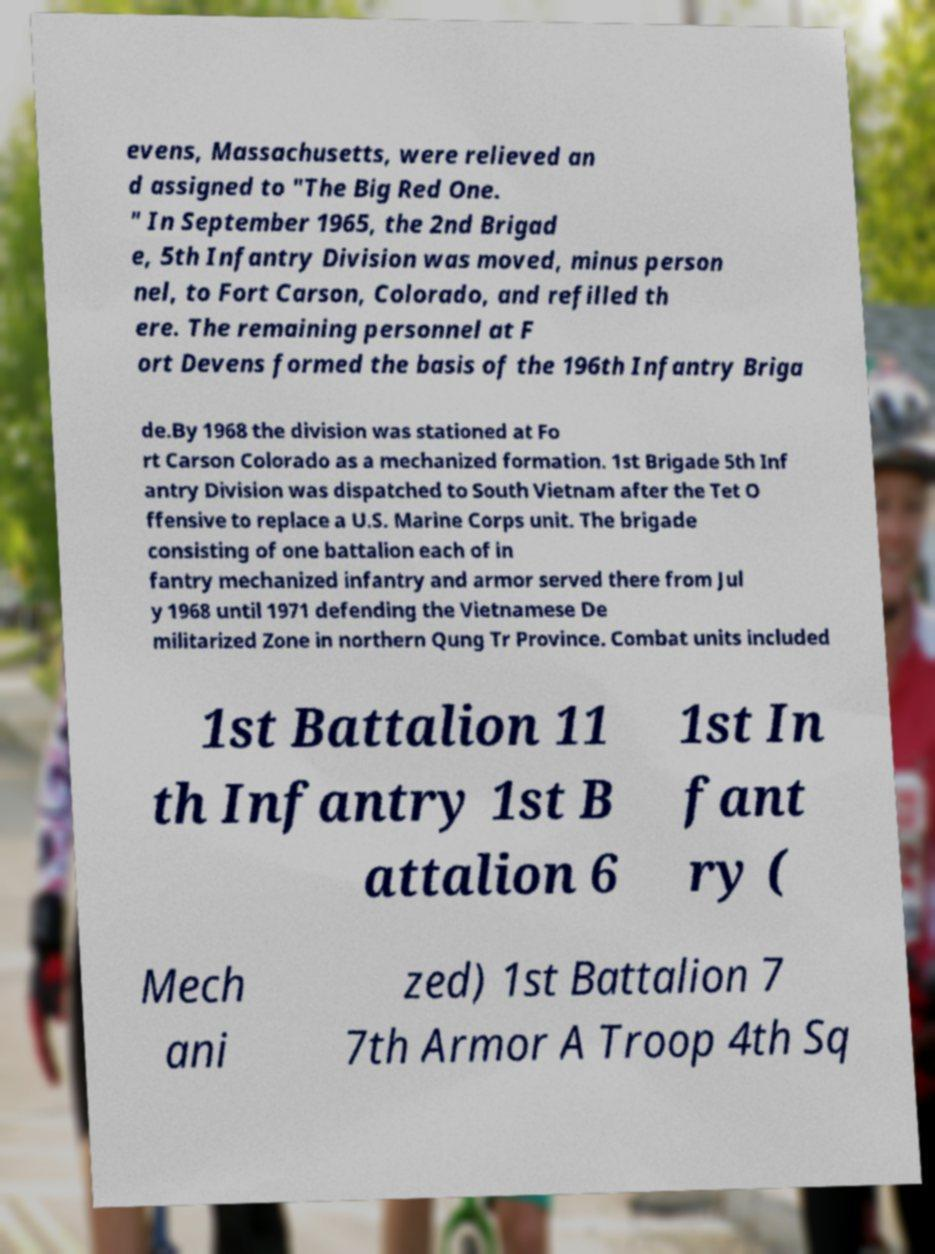For documentation purposes, I need the text within this image transcribed. Could you provide that? evens, Massachusetts, were relieved an d assigned to "The Big Red One. " In September 1965, the 2nd Brigad e, 5th Infantry Division was moved, minus person nel, to Fort Carson, Colorado, and refilled th ere. The remaining personnel at F ort Devens formed the basis of the 196th Infantry Briga de.By 1968 the division was stationed at Fo rt Carson Colorado as a mechanized formation. 1st Brigade 5th Inf antry Division was dispatched to South Vietnam after the Tet O ffensive to replace a U.S. Marine Corps unit. The brigade consisting of one battalion each of in fantry mechanized infantry and armor served there from Jul y 1968 until 1971 defending the Vietnamese De militarized Zone in northern Qung Tr Province. Combat units included 1st Battalion 11 th Infantry 1st B attalion 6 1st In fant ry ( Mech ani zed) 1st Battalion 7 7th Armor A Troop 4th Sq 